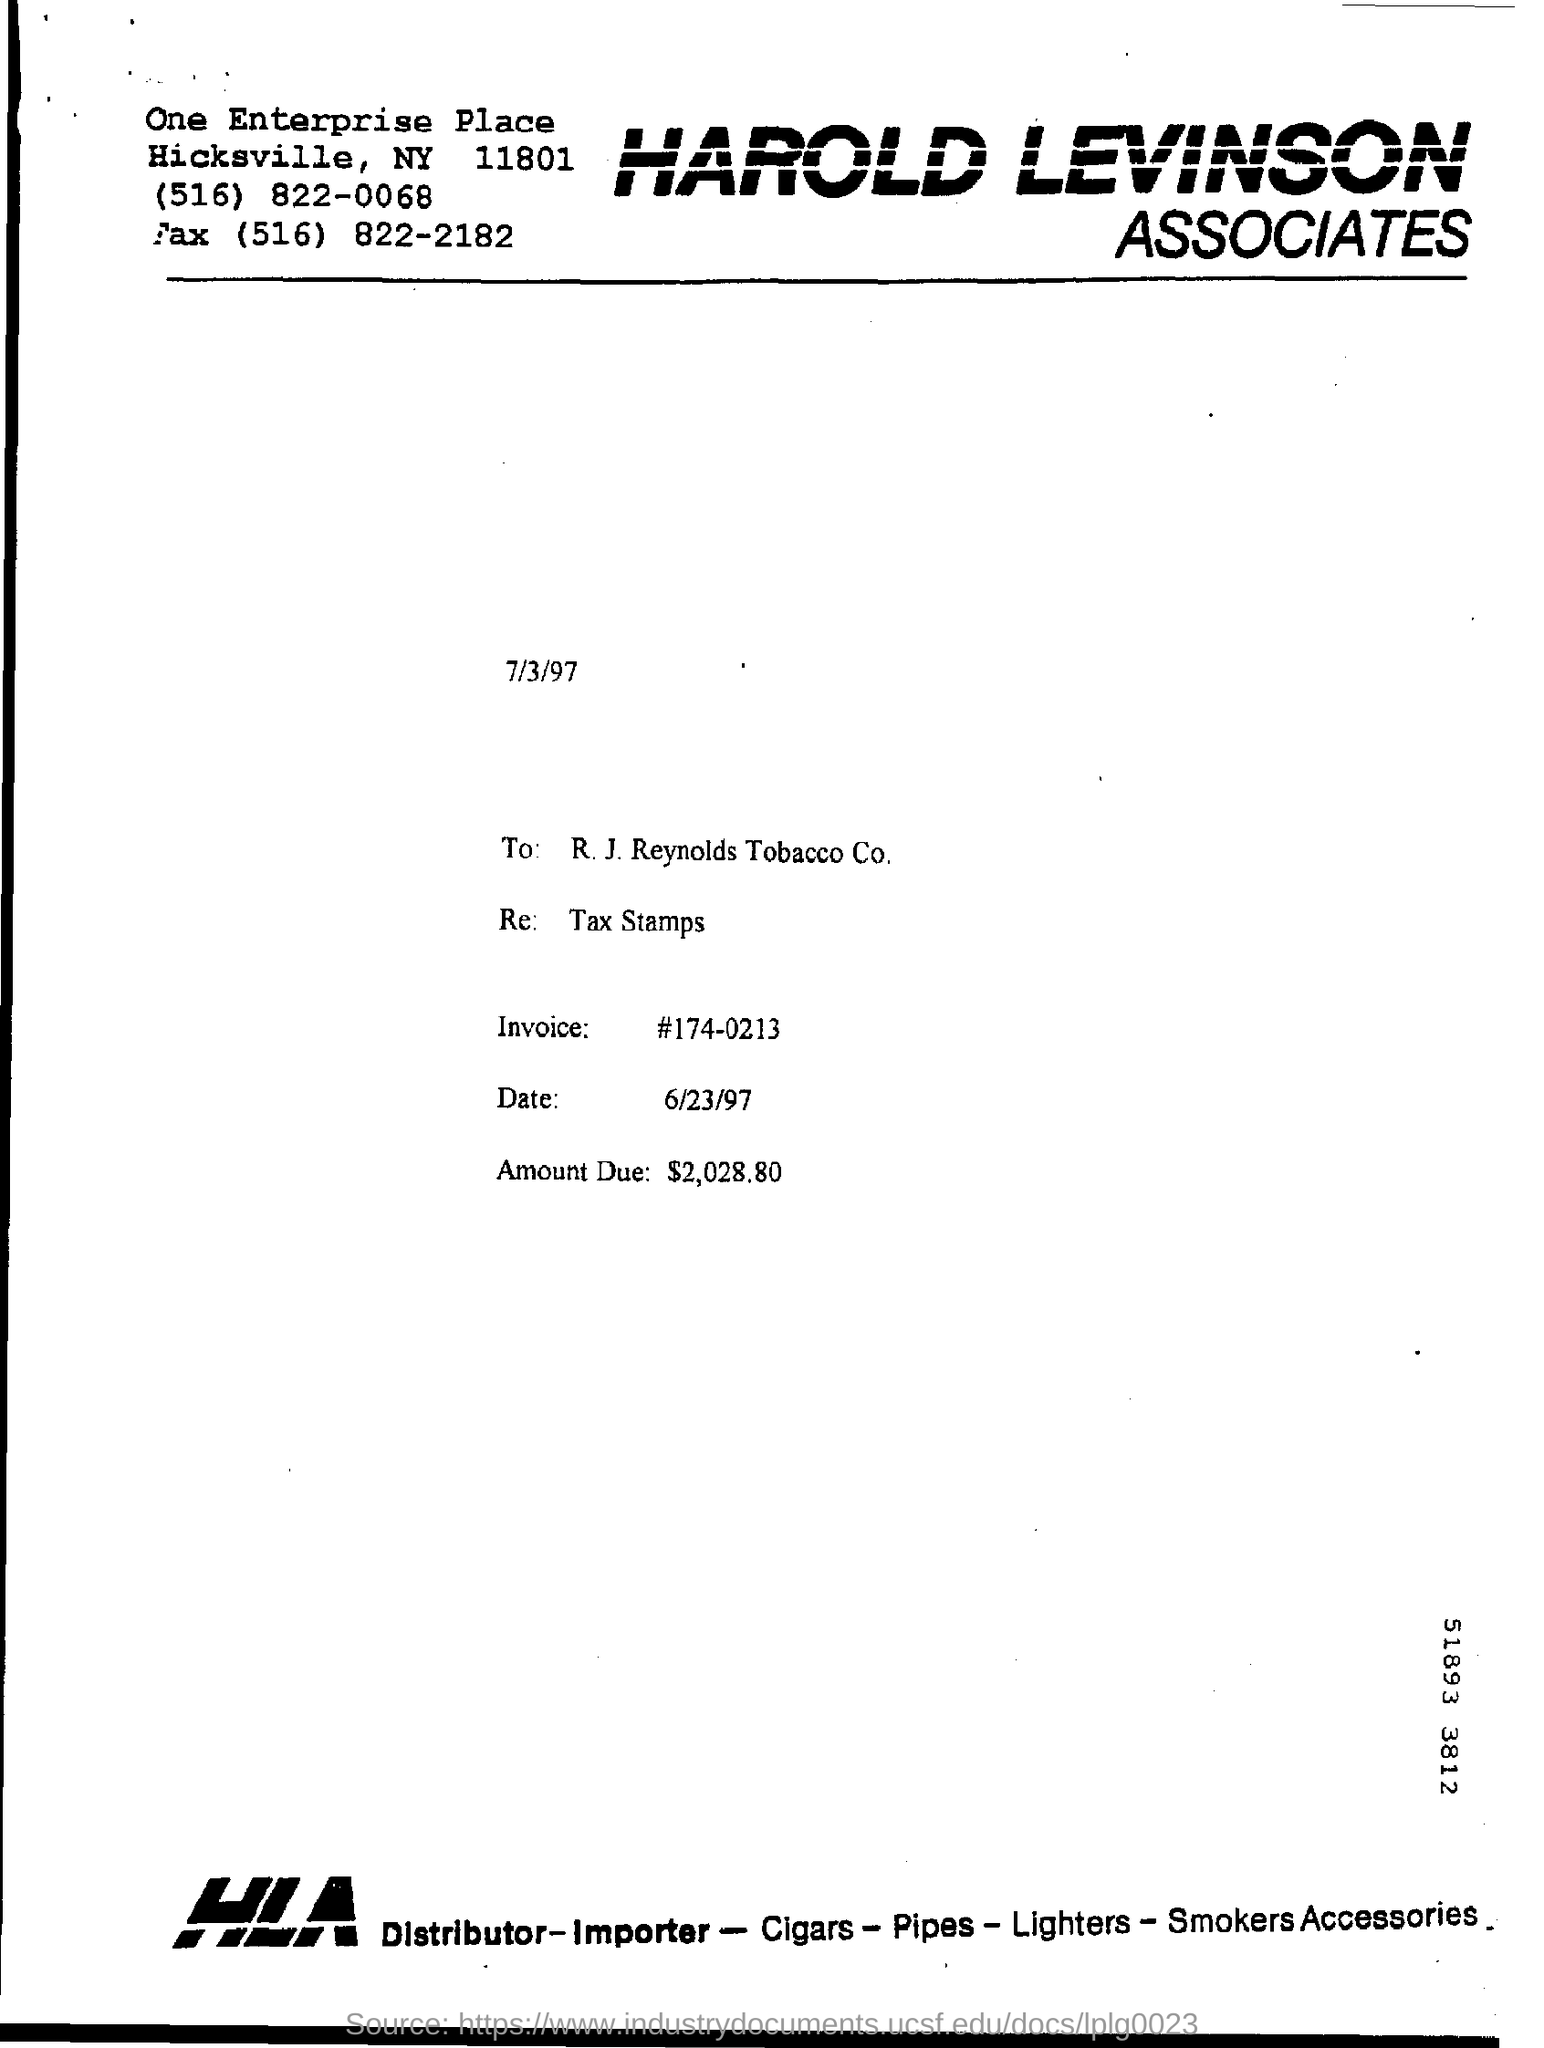What is the invoice number?
Offer a very short reply. #174-0213. What is the amount due mention in the document ?
Make the answer very short. 2,028.80. 